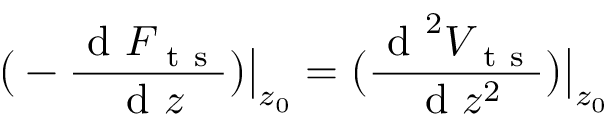<formula> <loc_0><loc_0><loc_500><loc_500>\left ( - \frac { d F _ { t s } } { d z } \right ) \left | _ { z _ { 0 } } = \left ( \frac { d ^ { 2 } V _ { t s } } { d z ^ { 2 } } \right ) \right | _ { z _ { 0 } }</formula> 